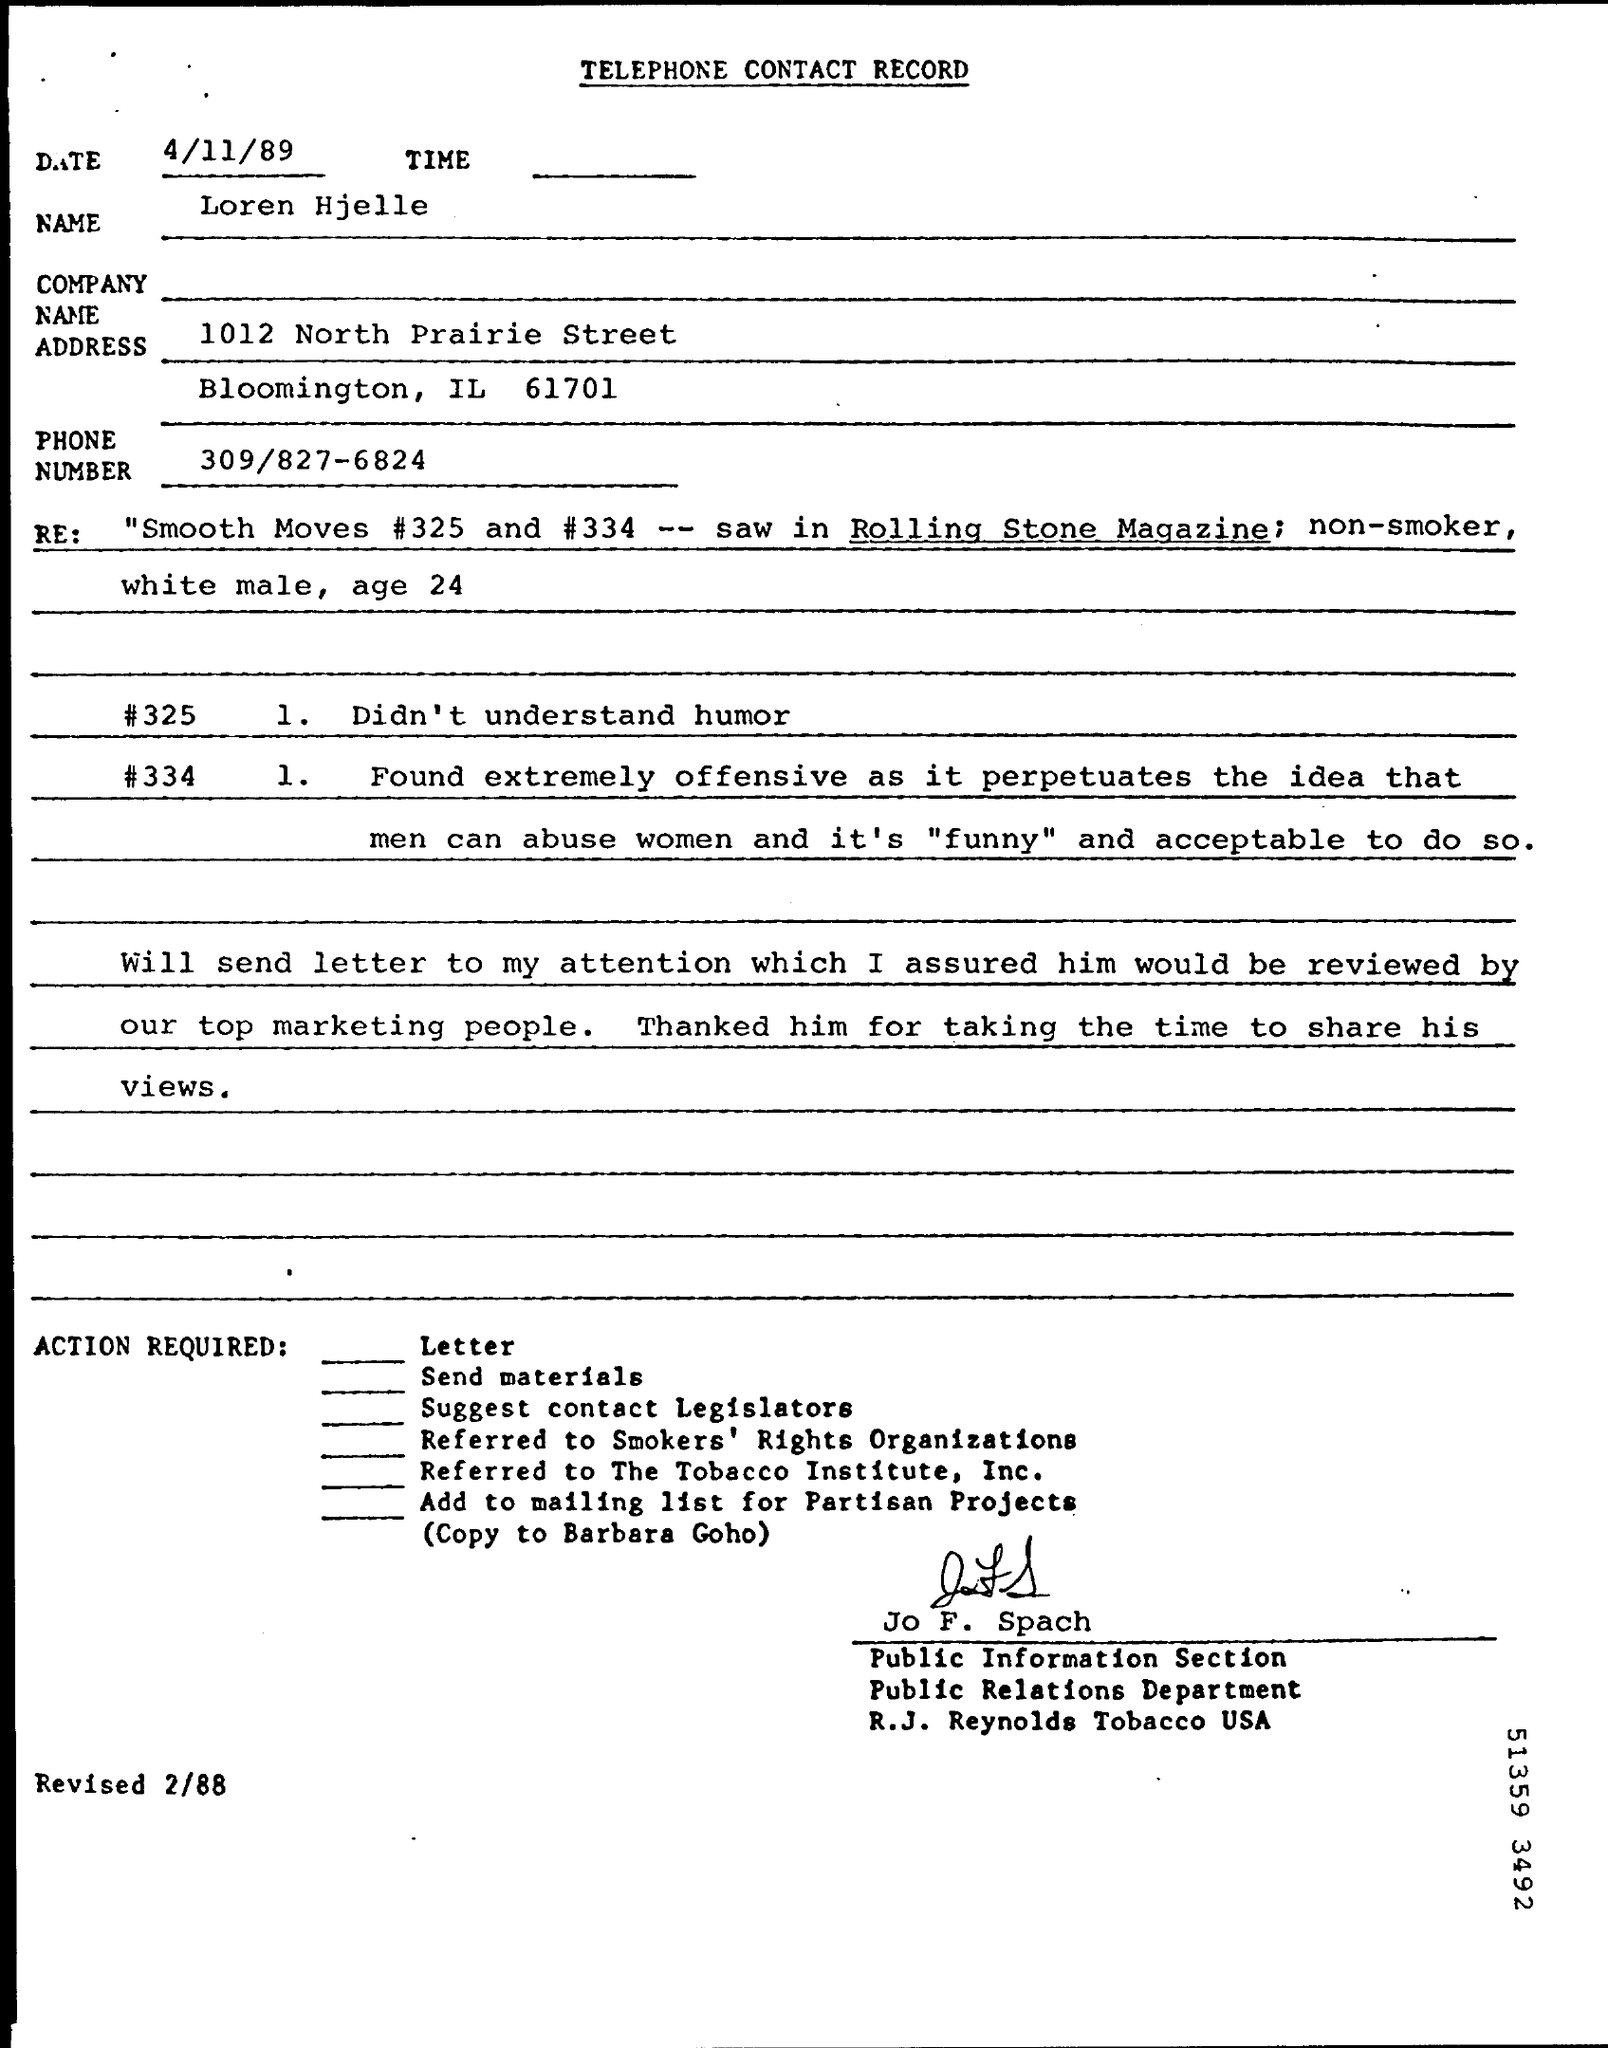What are the reactions recorded in this telephone contact record concerning the 'Smooth Moves' articles? The record notes that one person did not understand the humor in the 'Smooth Moves' articles, while another found them extremely offensive as they felt the content jokingly normalized the mistreatment of women. 